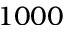<formula> <loc_0><loc_0><loc_500><loc_500>1 0 0 0</formula> 